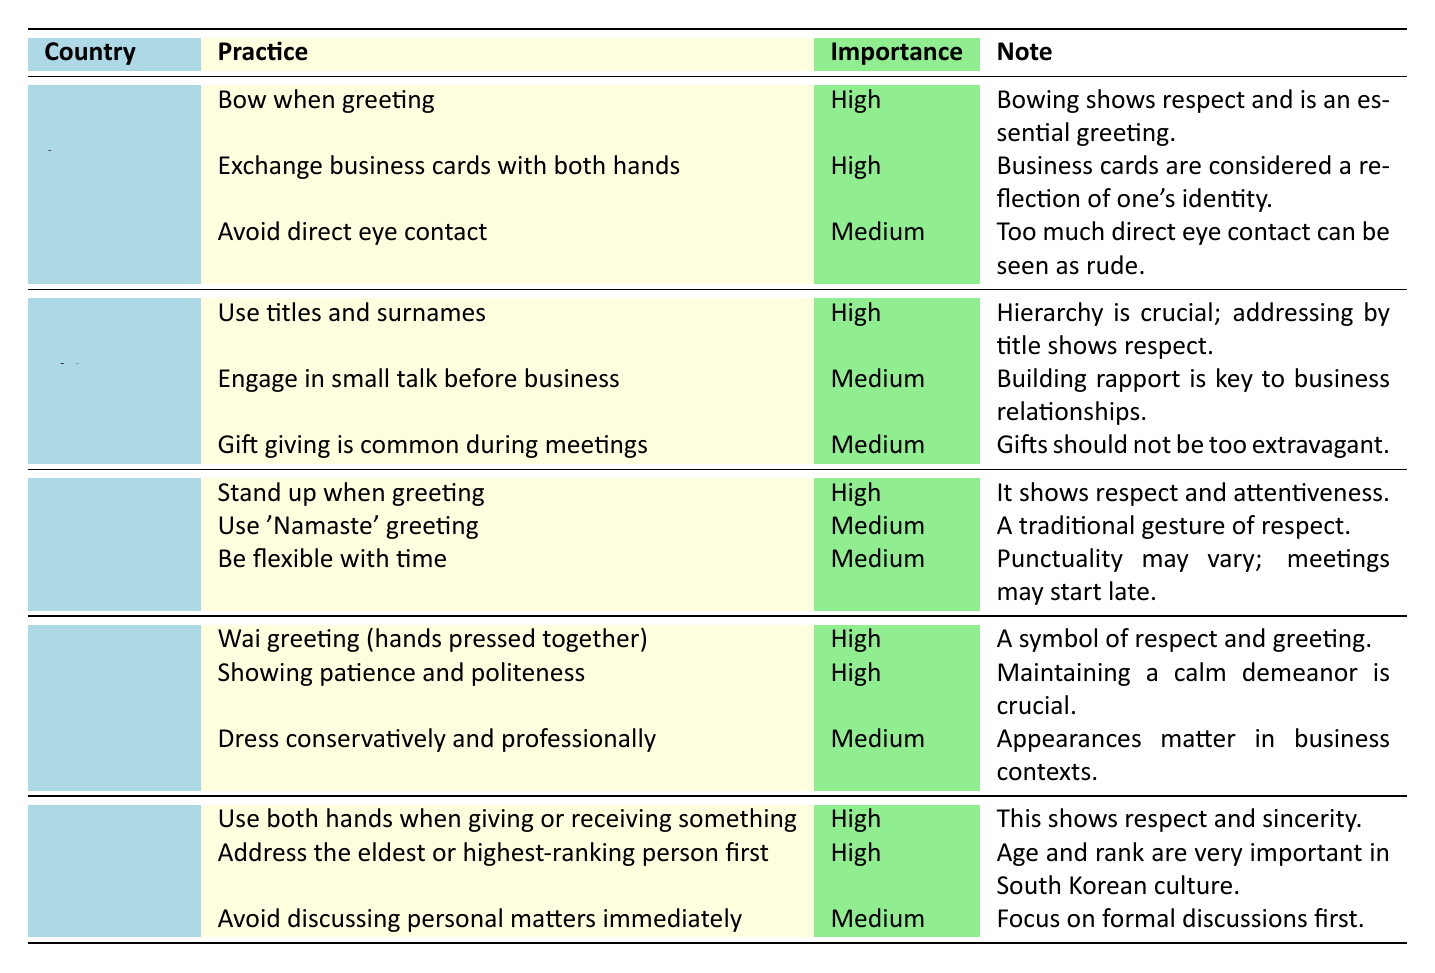What is the most important business practice in Japan? The table indicates that both "Bow when greeting" and "Exchange business cards with both hands" are marked as high importance for business etiquette in Japan. Since both practices are tied in importance, either could be considered the most important.
Answer: Bow when greeting or Exchange business cards with both hands How many high importance practices are listed for Thailand? Referring to the Thailand section in the table, there are two practices marked as high importance: "Wai greeting (hands pressed together)" and "Showing patience and politeness." Therefore, the total count is 2.
Answer: 2 Is gift giving considered important in business practice in China? Yes, the table shows that "Gift giving is common during meetings" is listed as medium importance, indicating it is a recognized practice but not as important as others.
Answer: Yes Which country emphasizes the use of titles and surnames the most in business etiquette? The table indicates that China has the practice "Use titles and surnames," marked as high importance, while other countries have varying levels of importance for similar practices. Thus, China is the country that emphasizes this the most.
Answer: China In how many countries is "high importance" given to greeting methods? Analyzing each country, Japan, Thailand, and South Korea all have high importance practices related to greetings: "Bow when greeting," "Wai greeting," and "Use both hands when giving or receiving something." Therefore, this sums to three countries.
Answer: 3 Is it necessary to avoid direct eye contact in Japan? The table states that "Avoid direct eye contact" has medium importance in Japan, suggesting it is advisable but not strictly necessary.
Answer: No What is the collective total of high importance practices across all countries listed? Upon examining the table, high importance practices are noted 2 in Japan, 1 in China, 1 in India, 2 in Thailand, and 2 in South Korea. Adding these together gives: 2 + 1 + 1 + 2 + 2 = 8.
Answer: 8 Which practice is noted as significant for showing respect when greeting in India? The table specifies that "Stand up when greeting" is identified as a high importance practice in India, highlighting its role in showing respect.
Answer: Stand up when greeting For which country is it noted that flexibility with time is important? According to the table, India includes "Be flexible with time" as a medium importance practice, indicating the variability in punctuality during business meetings.
Answer: India What practice is common across multiple countries that indicates respect? The practice of greeting is highlighted across several countries, specifically "Bow when greeting" in Japan, "Wai greeting" in Thailand, and "Use both hands" in South Korea. All these indicate respect in their respective cultures.
Answer: Greeting methods (bowing, wai, using both hands) 